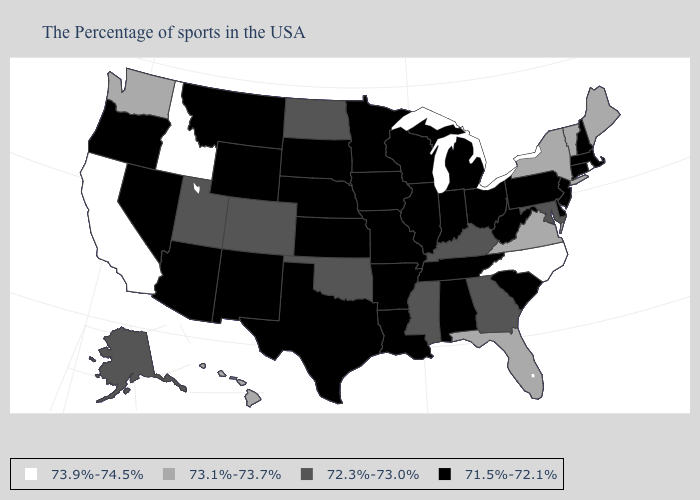Name the states that have a value in the range 72.3%-73.0%?
Quick response, please. Maryland, Georgia, Kentucky, Mississippi, Oklahoma, North Dakota, Colorado, Utah, Alaska. Name the states that have a value in the range 73.9%-74.5%?
Be succinct. Rhode Island, North Carolina, Idaho, California. What is the value of Florida?
Answer briefly. 73.1%-73.7%. Which states have the lowest value in the South?
Answer briefly. Delaware, South Carolina, West Virginia, Alabama, Tennessee, Louisiana, Arkansas, Texas. Is the legend a continuous bar?
Be succinct. No. Does Vermont have the highest value in the Northeast?
Quick response, please. No. Among the states that border Texas , does New Mexico have the lowest value?
Quick response, please. Yes. Which states have the highest value in the USA?
Give a very brief answer. Rhode Island, North Carolina, Idaho, California. Name the states that have a value in the range 73.1%-73.7%?
Give a very brief answer. Maine, Vermont, New York, Virginia, Florida, Washington, Hawaii. Does the first symbol in the legend represent the smallest category?
Give a very brief answer. No. Name the states that have a value in the range 73.9%-74.5%?
Short answer required. Rhode Island, North Carolina, Idaho, California. What is the value of Hawaii?
Be succinct. 73.1%-73.7%. What is the value of North Dakota?
Write a very short answer. 72.3%-73.0%. Name the states that have a value in the range 71.5%-72.1%?
Quick response, please. Massachusetts, New Hampshire, Connecticut, New Jersey, Delaware, Pennsylvania, South Carolina, West Virginia, Ohio, Michigan, Indiana, Alabama, Tennessee, Wisconsin, Illinois, Louisiana, Missouri, Arkansas, Minnesota, Iowa, Kansas, Nebraska, Texas, South Dakota, Wyoming, New Mexico, Montana, Arizona, Nevada, Oregon. 